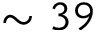<formula> <loc_0><loc_0><loc_500><loc_500>\sim 3 9</formula> 